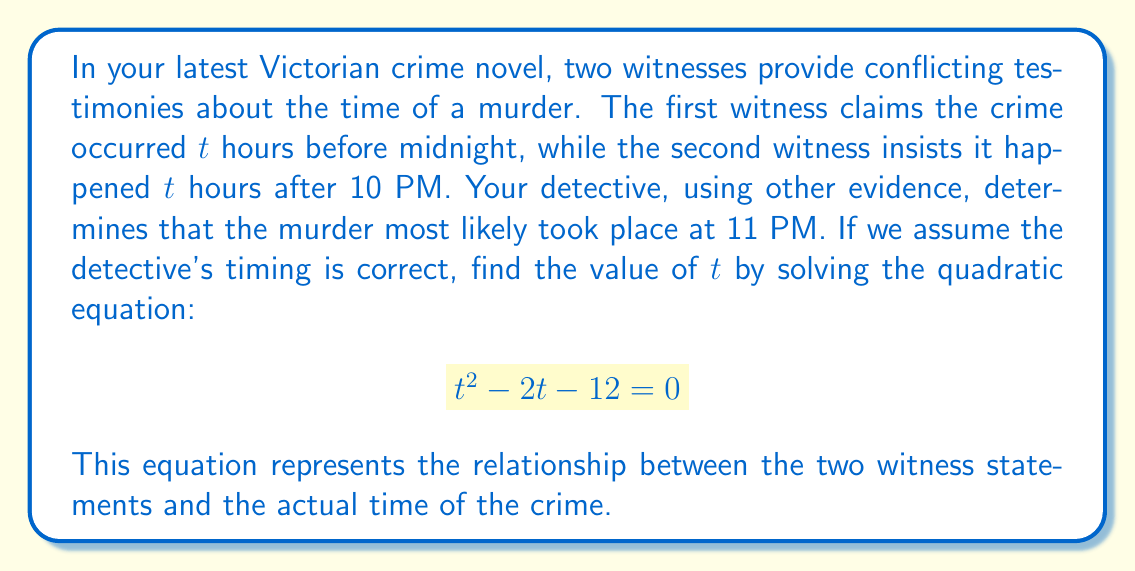What is the answer to this math problem? Let's solve this quadratic equation step by step:

1) We start with the equation $t^2 - 2t - 12 = 0$

2) This is in the standard form of a quadratic equation: $at^2 + bt + c = 0$, where $a=1$, $b=-2$, and $c=-12$

3) We can solve this using the quadratic formula: $t = \frac{-b \pm \sqrt{b^2 - 4ac}}{2a}$

4) Substituting our values:
   $t = \frac{-(-2) \pm \sqrt{(-2)^2 - 4(1)(-12)}}{2(1)}$

5) Simplifying:
   $t = \frac{2 \pm \sqrt{4 + 48}}{2} = \frac{2 \pm \sqrt{52}}{2} = \frac{2 \pm 2\sqrt{13}}{2}$

6) This gives us two solutions:
   $t = 1 + \sqrt{13}$ or $t = 1 - \sqrt{13}$

7) Since time cannot be negative in this context, we can discard the negative solution.

8) Therefore, $t = 1 + \sqrt{13} \approx 4.61$ hours

This means the crime occurred about 4.61 hours before midnight, which is indeed 11 PM (as 12 - 4.61 ≈ 7.39, or 11:23 PM rounded to the nearest hour).
Answer: $t = 1 + \sqrt{13} \approx 4.61$ hours 